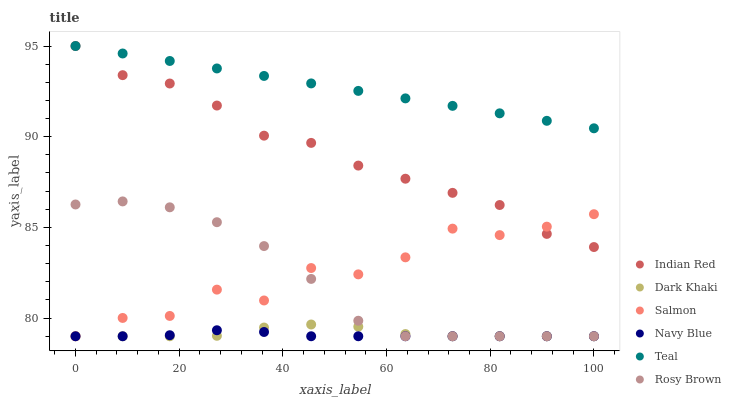Does Navy Blue have the minimum area under the curve?
Answer yes or no. Yes. Does Teal have the maximum area under the curve?
Answer yes or no. Yes. Does Rosy Brown have the minimum area under the curve?
Answer yes or no. No. Does Rosy Brown have the maximum area under the curve?
Answer yes or no. No. Is Teal the smoothest?
Answer yes or no. Yes. Is Salmon the roughest?
Answer yes or no. Yes. Is Navy Blue the smoothest?
Answer yes or no. No. Is Navy Blue the roughest?
Answer yes or no. No. Does Navy Blue have the lowest value?
Answer yes or no. Yes. Does Teal have the lowest value?
Answer yes or no. No. Does Teal have the highest value?
Answer yes or no. Yes. Does Rosy Brown have the highest value?
Answer yes or no. No. Is Rosy Brown less than Teal?
Answer yes or no. Yes. Is Indian Red greater than Rosy Brown?
Answer yes or no. Yes. Does Rosy Brown intersect Dark Khaki?
Answer yes or no. Yes. Is Rosy Brown less than Dark Khaki?
Answer yes or no. No. Is Rosy Brown greater than Dark Khaki?
Answer yes or no. No. Does Rosy Brown intersect Teal?
Answer yes or no. No. 